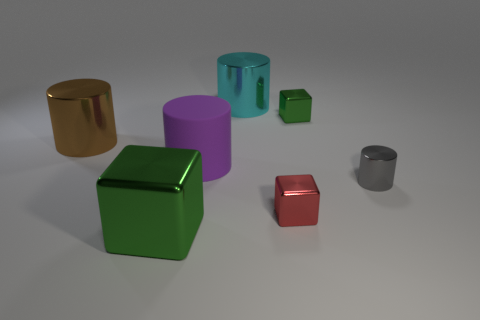Could you tell me what colors and shapes are present in this collection of objects? The image showcases a variety of colors and shapes. We have objects in gold, purple, teal, green, red, and silver. As for shapes, there are cylinders, cubes, and what appears to be a single rectangular prism. Each color has been applied to objects of different shapes, creating a visually diverse set. 